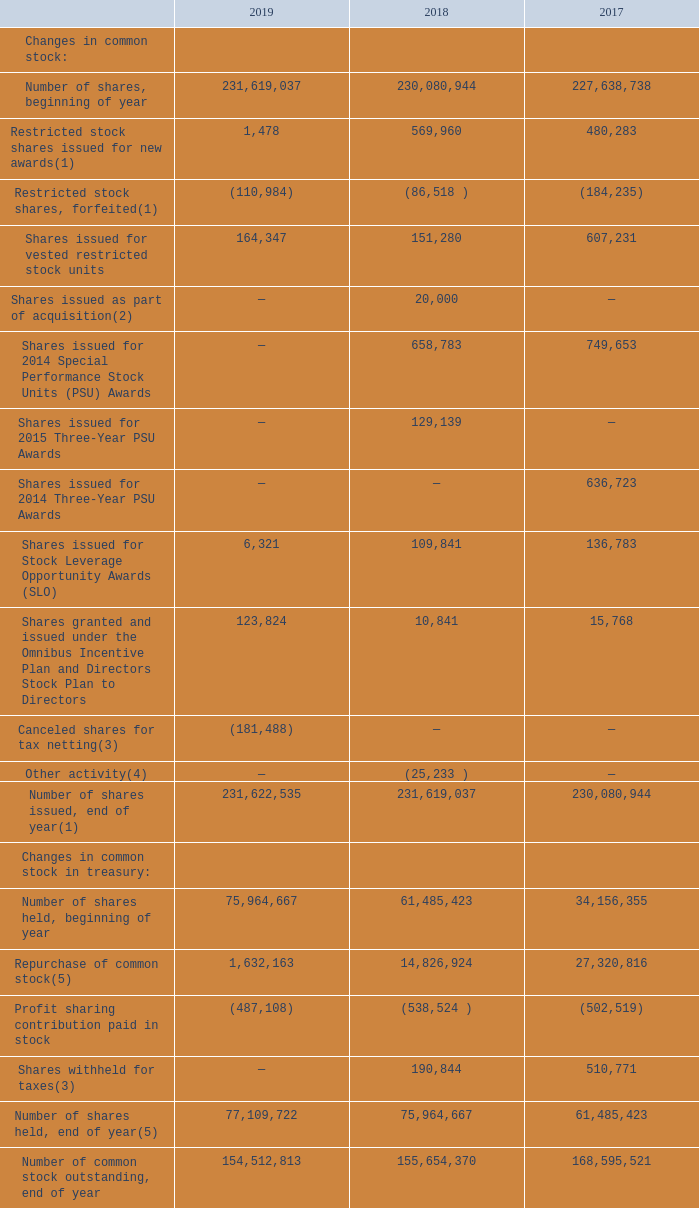Common Stock
The following is a summary of changes during the years ended December 31, in shares of our common stock and common stock in treasury:
(1) Restricted stock shares issued for new awards under the Omnibus Incentive Plan and restricted stock shares, forfeited as shown above for the year ended December 31, 2019 includes 1,478 restricted stock shares issued and (5,024) restricted stock shares forfeited related to 2018 that were not yet reflected by our Recordkeeper as of December 31, 2018. The table above and our Consolidated Balance Sheets reflect the number of shares issued per our Recordkeeper.
(2) In connection with the acquisition of B+ Equipment in the third quarter of 2015, the Company issued 20,000 shares of restricted common stock on September 26, 2018 to certain former equity holders of B+ Equipment. These shares were issued in offshore transactions with no direct selling efforts in the United States and without registration under the Securities Act of 1933, as amended, in reliance upon the issuer safe harbor provided by Regulation S.
(3) Effective January 1, 2019, new share issuances for vested awards are netted by the number of shares required to cover the recipients' portion of income tax. The portion withheld for taxes are canceled. Prior to January 1, 2019, the shares required to cover the recipients' portion of income tax were issued and recorded to treasury stock. Shares netted for taxes in 2019 primarily relates to vesting activity for restricted stock shares issued in prior years.
(4) Other activity in 2018 primarily relates to prior period adjustment related to years not contained within the table.
(5) Repurchase of common stock for the year ended December 31, 2019 as shown above includes 71,530 shares of common stock that had been repurchased by the Company in 2018 but not yet reflected by the Recordkeeper as of December 31, 2018. The table above and our Consolidated Balance Sheets reflect the number of shares held in treasury per our Recordkeeper.
What does the table show? Summary of changes during the years ended december 31, in shares of our common stock and common stock in treasury. What does the Repurchase of common stock for the year ended December 31, 2019 as shown above include that is not yet reflected by the Recordkeeper as of December 31, 2018? 71,530 shares of common stock that had been repurchased by the company in 2018. What is the Number of common stock outstanding, end of year for 2019? 154,512,813. What is the Number of shares held, end of year expressed as a percentage of Number of common stock outstanding, end of year?
Answer scale should be: percent. 77,109,722/154,512,813
Answer: 49.91. What is the percentage change of the Number of shares held, end of year from 2017 to 2018?
Answer scale should be: percent. (75,964,667-61,485,423)/61,485,423
Answer: 23.55. What is the number of shares issued, end of year excluding 1,478 restricted stock shares issued and (5,024) restricted stock shares for 2019? 231,622,535-(1,478-(-5,024))
Answer: 231616033. 